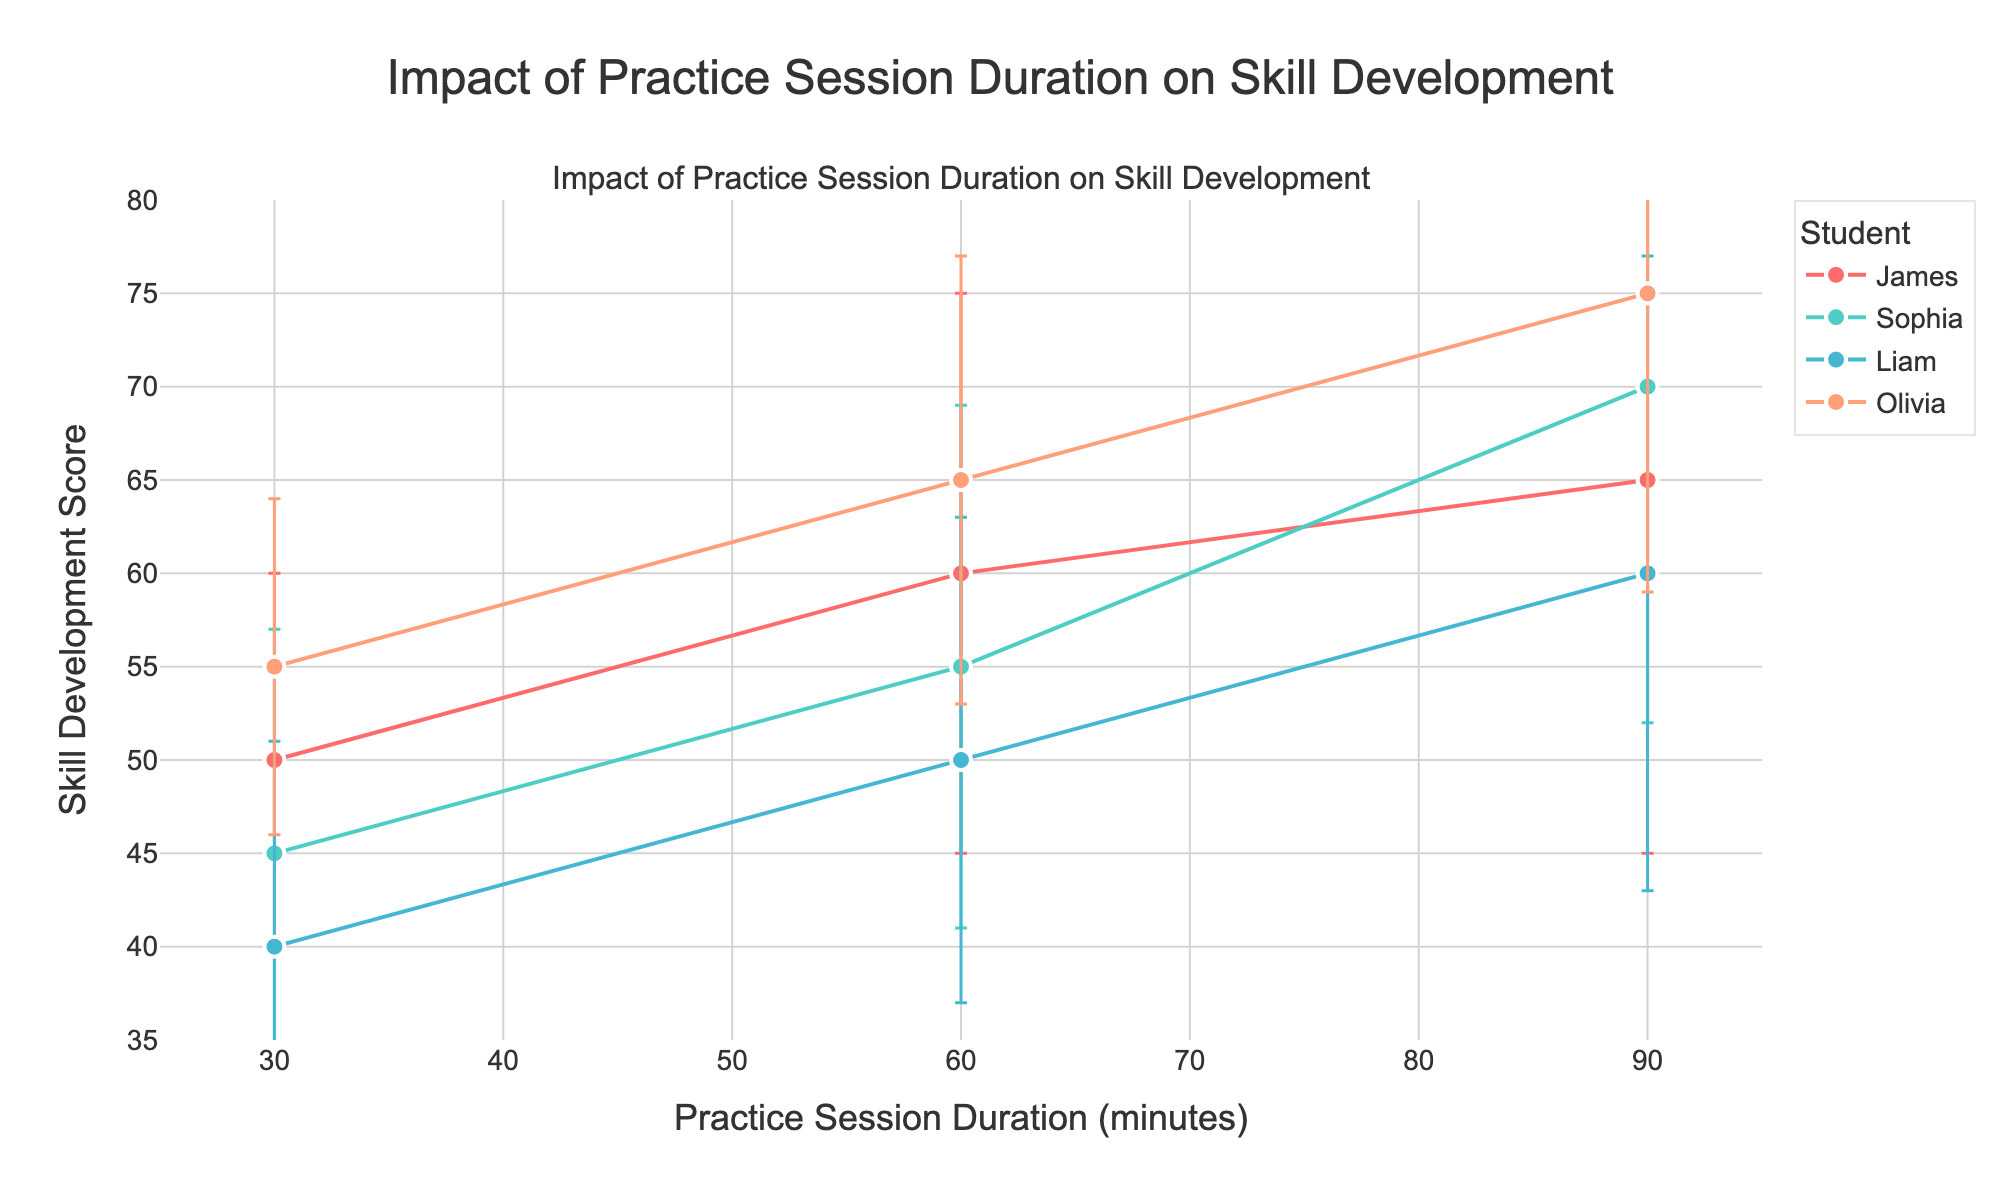What's the title of the figure? The title of the figure is displayed at the top of the plot and reads "Impact of Practice Session Duration on Skill Development".
Answer: Impact of Practice Session Duration on Skill Development What does the x-axis represent? The x-axis, which has labels at the bottom of the figure, represents "Practice Session Duration (minutes)".
Answer: Practice Session Duration (minutes) What does the y-axis represent? The label on the left side of the figure indicates that the y-axis represents "Skill Development Score".
Answer: Skill Development Score Which student has the highest Skill Development Score at 90 minutes of practice? By looking at the plot, each student's scores at 90 minutes of practice can be compared. Olivia has the highest score at 90 minutes.
Answer: Olivia Which student shows the smallest standard deviation in Skill Development Score at 30 minutes of practice? By comparing the error bars at 30 minutes for each student, Olivia has the smallest standard deviation as her error bars are the shortest.
Answer: Olivia How does James’s skill development change as practice session duration increases from 30 to 90 minutes? Observing James's data points, his Skill Development Score increases from 50 at 30 minutes to 65 at 90 minutes, with scores of 60 at 60 minutes in between. Thus, James's skill development increases with more practice duration.
Answer: Increases Which student shows the most consistent Skill Development Score across different practice durations? Consistency can be determined by the smallest standard deviation throughout all data points. Olivia has the smallest error bars overall, indicating the most consistency.
Answer: Olivia Which students have overlapping Skill Development Scores at 60 minutes despite their average scores being different? Comparing the error bars at 60 minutes, we notice that James, Sophia, and Liam have overlapping ranges due to their standard deviations. Olivia's range does not overlap with the others’.
Answer: James, Sophia, Liam What is the range of Skill Development Scores for Sophia at 60 minutes of practice? Sophia's mean score at 60 minutes is 55 with a standard deviation of 14. The range is from (55 - 14) to (55 + 14), which is 41 to 69.
Answer: 41 to 69 